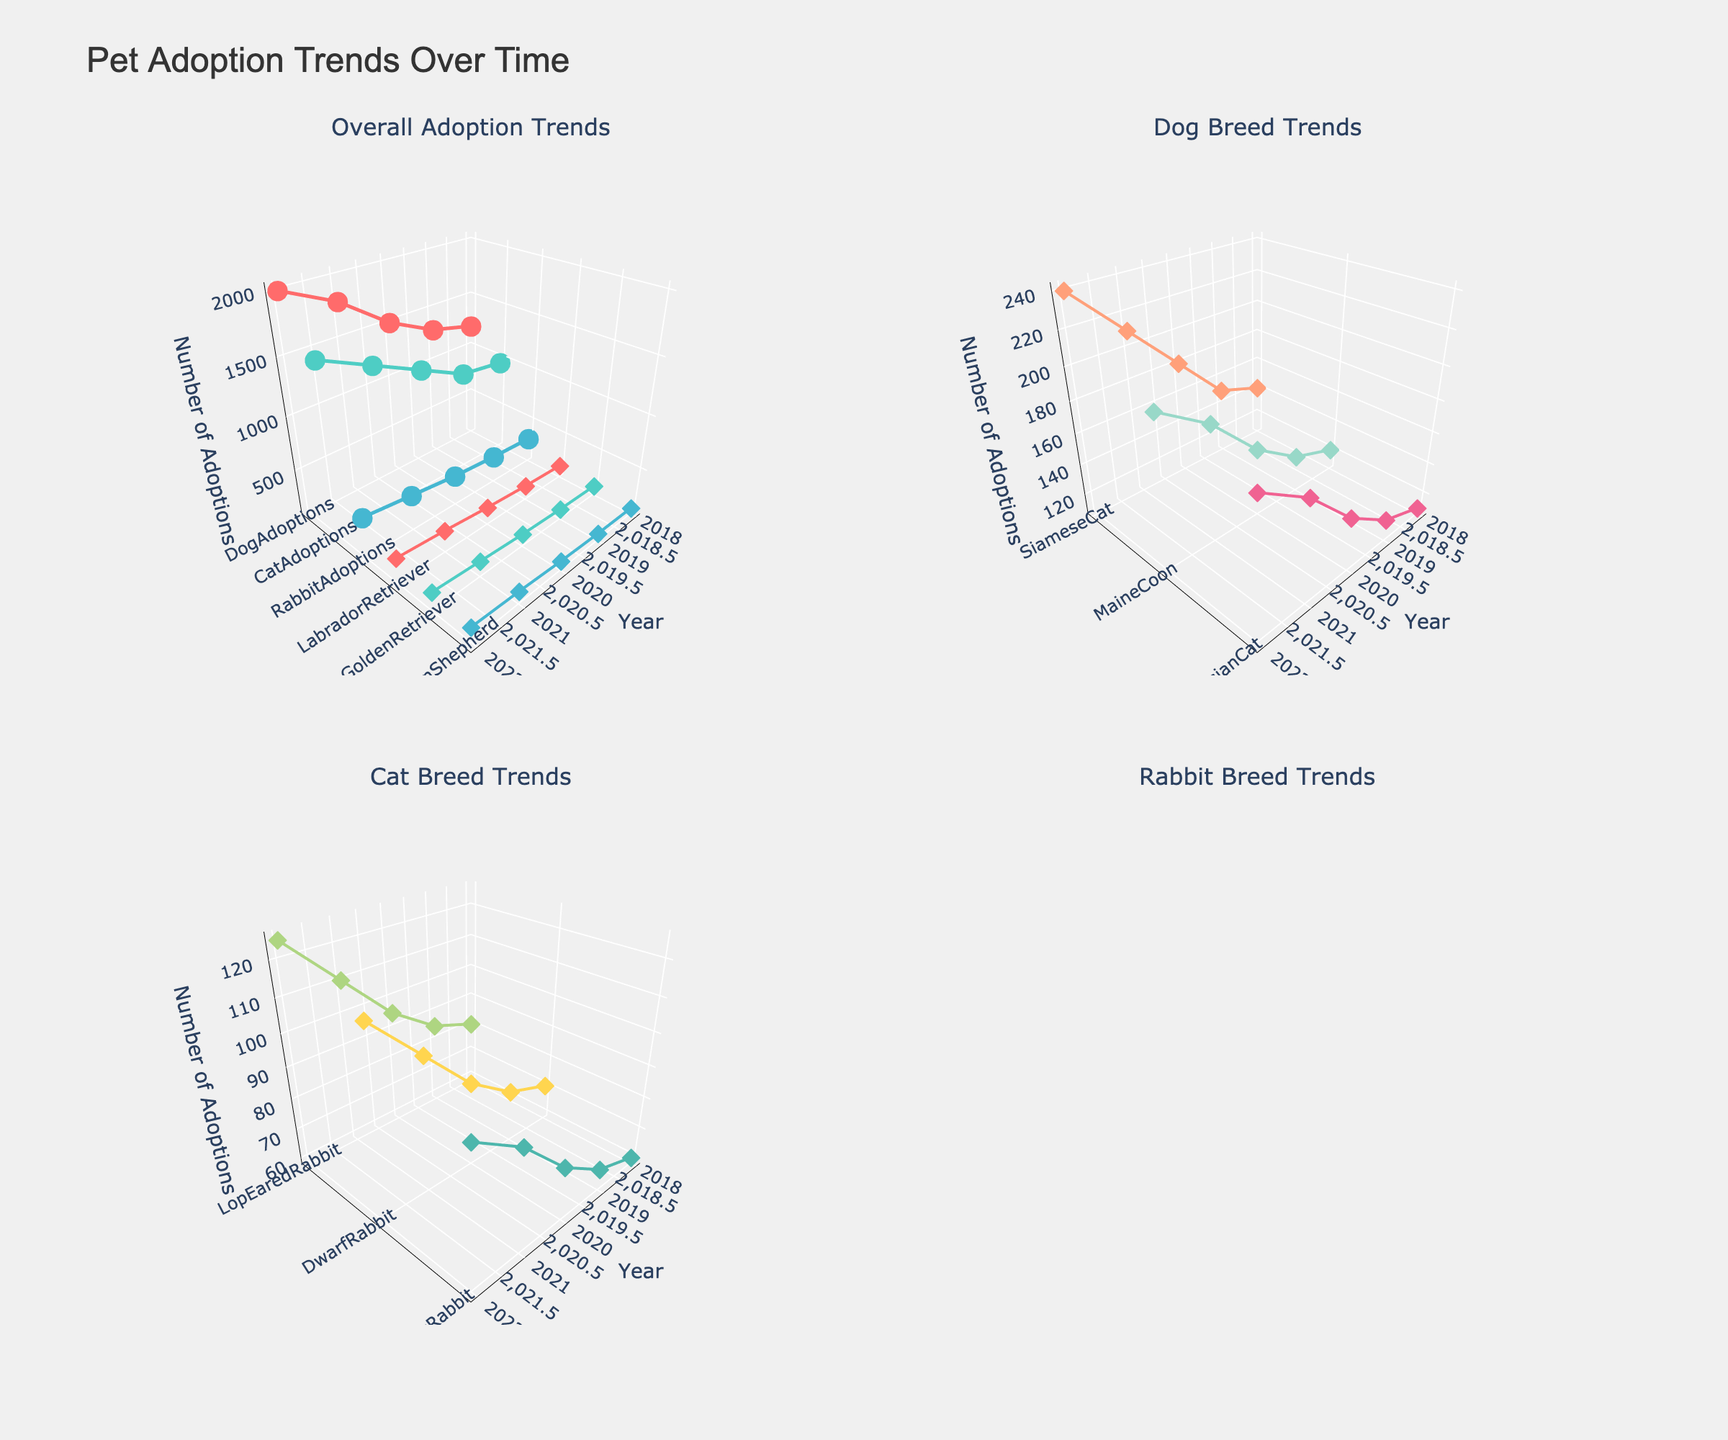What is the title of the plot? The title of the plot can be found at the top center of the figure. It provides an overall description of what the figure is about.
Answer: Pet Adoption Trends Over Time In the overall adoption trends subplot, which animal had the highest number of adoptions in 2022? To find this, look at the 'Overall Adoption Trends' subplot, locate the 2022 data points on the x-axis, and compare the z-values (number of adoptions) for dogs, cats, and rabbits.
Answer: Dogs Between which years did dog adoptions see the largest increase? In the 'Overall Adoption Trends' subplot, observe the z-axis values for dogs from year to year and identify the years between which there was the largest increase.
Answer: 2020 and 2021 Which rabbit breed showed the most consistent increase from 2018 to 2022? In the 'Rabbit Breed Trends' subplot, analyze each breed's line trend from 2018 to 2022 and identify which one showed a steady increase.
Answer: Lop Eared Rabbit How many data points are represented in the cat breed trends subplot? To determine this, count the number of years (x-axis values) for each cat breed in the 'Cat Breed Trends' subplot. Each breed should have one data point per year.
Answer: 15 Compare the adoptions of Golden Retrievers and German Shepherds in 2020. Which was higher and by how much? In the 'Dog Breed Trends' subplot, look at the z-values for Golden Retrievers and German Shepherds in 2020 and subtract the smaller value from the larger value to find the difference.
Answer: Golden Retrievers by 30 Which pet type had the smallest increase in adoptions from 2018 to 2022? Analyze the 'Overall Adoption Trends' subplot and compare the increase in the z-values of dogs, cats, and rabbits from 2018 to 2022. The one with the smallest increase is the answer.
Answer: Rabbits What was the number of adoptions for Maine Coon cats in 2021? In the 'Cat Breed Trends' subplot, locate the 2021 data point for Maine Coon cats and read the corresponding z-value.
Answer: 180 For which rabbit breed did adoptions increase the most sharply between 2021 and 2022? Examine the 'Rabbit Breed Trends' subplot, and compare the change in z-values between 2021 and 2022 for Lop Eared, Dwarf, and Rex Rabbits. Identify which breed had the greatest increase.
Answer: Rex Rabbit Which subplot shows the highest number of adoptions for any breed/type in any year, and which breed/type and year is it? Review all subplots and locate the highest peak in the z-axis across all years and breeds/types to identify both the subplot and the specific breed/type and year.
Answer: 'Overall Adoption Trends' subplot, Dogs in 2022 